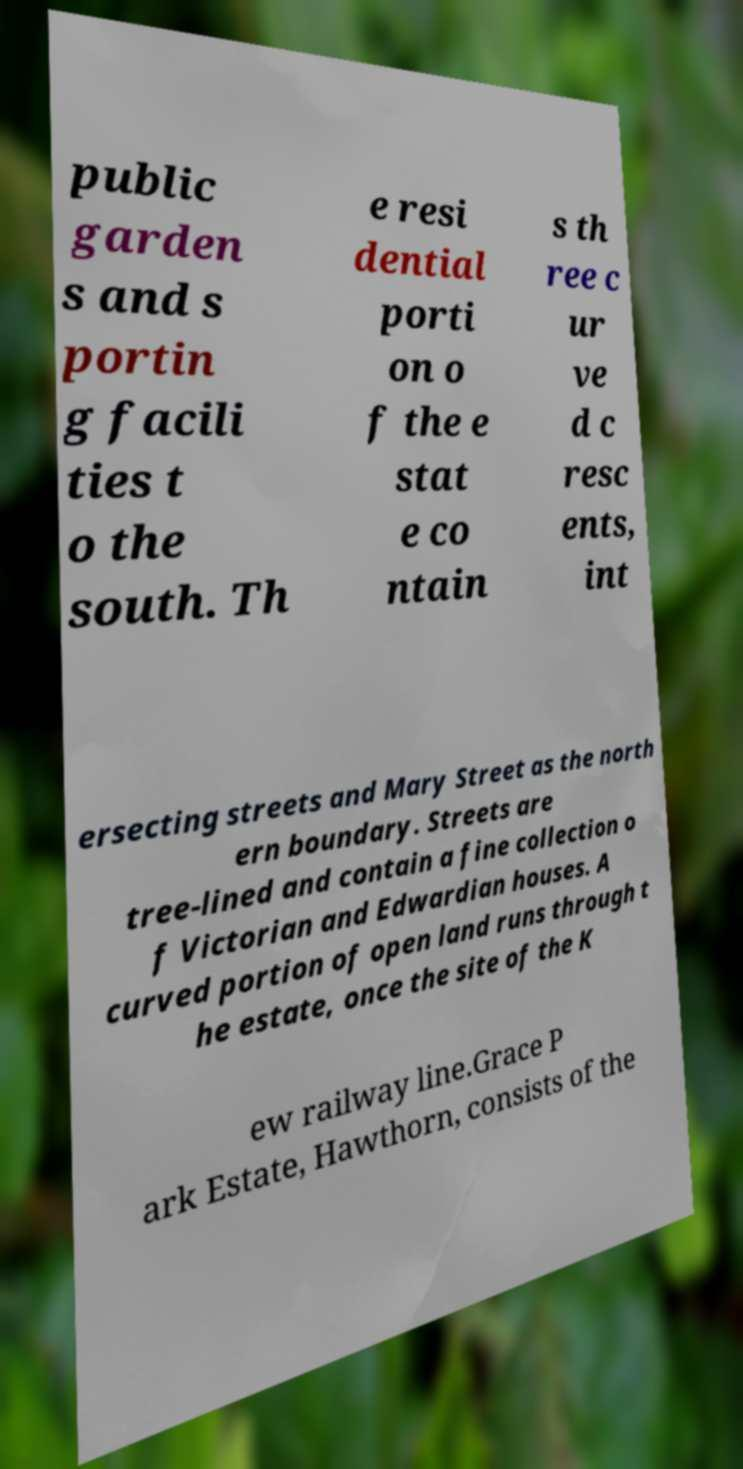I need the written content from this picture converted into text. Can you do that? public garden s and s portin g facili ties t o the south. Th e resi dential porti on o f the e stat e co ntain s th ree c ur ve d c resc ents, int ersecting streets and Mary Street as the north ern boundary. Streets are tree-lined and contain a fine collection o f Victorian and Edwardian houses. A curved portion of open land runs through t he estate, once the site of the K ew railway line.Grace P ark Estate, Hawthorn, consists of the 